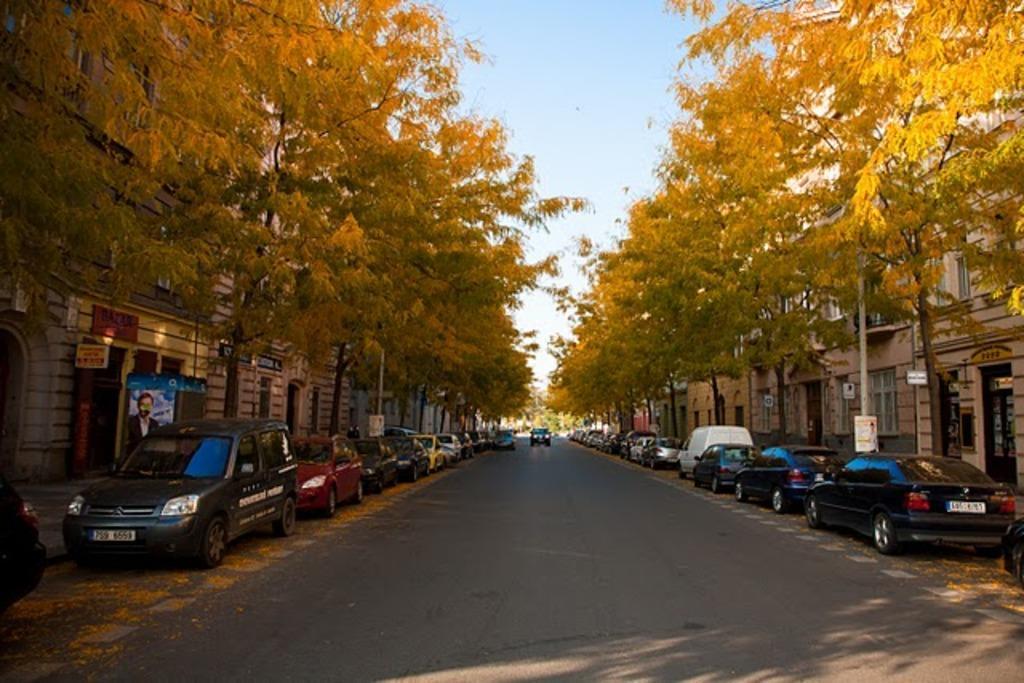Please provide a concise description of this image. In the middle this is the road, on either side of this road cars are parked and there are trees and buildings. At the top it's a sky. 